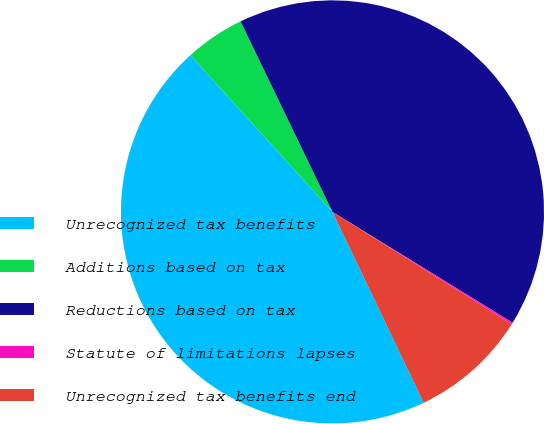Convert chart. <chart><loc_0><loc_0><loc_500><loc_500><pie_chart><fcel>Unrecognized tax benefits<fcel>Additions based on tax<fcel>Reductions based on tax<fcel>Statute of limitations lapses<fcel>Unrecognized tax benefits end<nl><fcel>45.37%<fcel>4.57%<fcel>40.94%<fcel>0.13%<fcel>9.0%<nl></chart> 